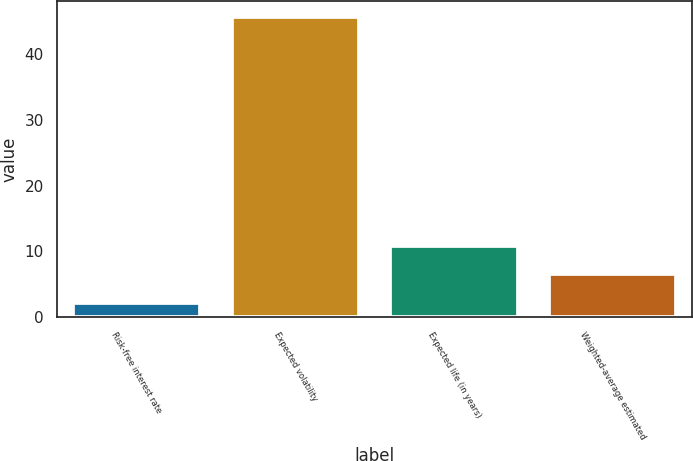Convert chart to OTSL. <chart><loc_0><loc_0><loc_500><loc_500><bar_chart><fcel>Risk-free interest rate<fcel>Expected volatility<fcel>Expected life (in years)<fcel>Weighted-average estimated<nl><fcel>2.18<fcel>45.63<fcel>10.88<fcel>6.53<nl></chart> 